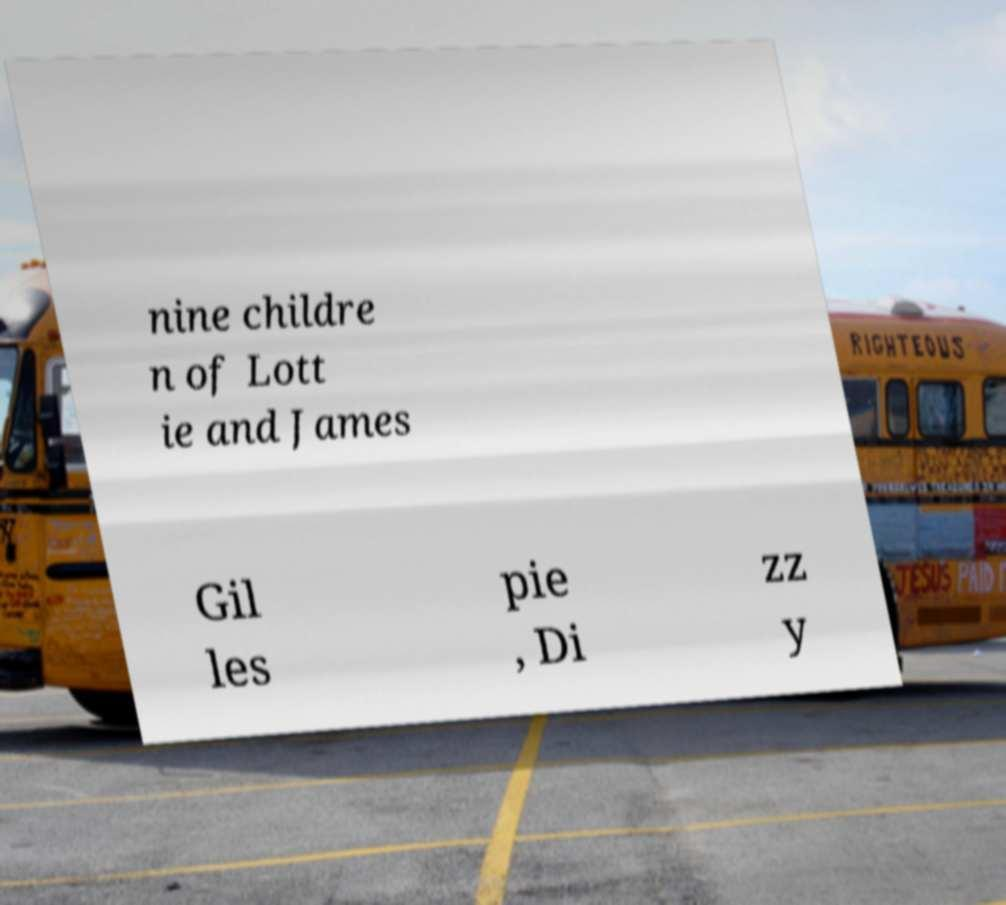There's text embedded in this image that I need extracted. Can you transcribe it verbatim? nine childre n of Lott ie and James Gil les pie , Di zz y 